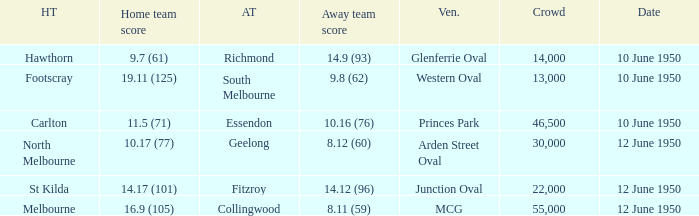Who was the away team when the VFL played at MCG? Collingwood. 